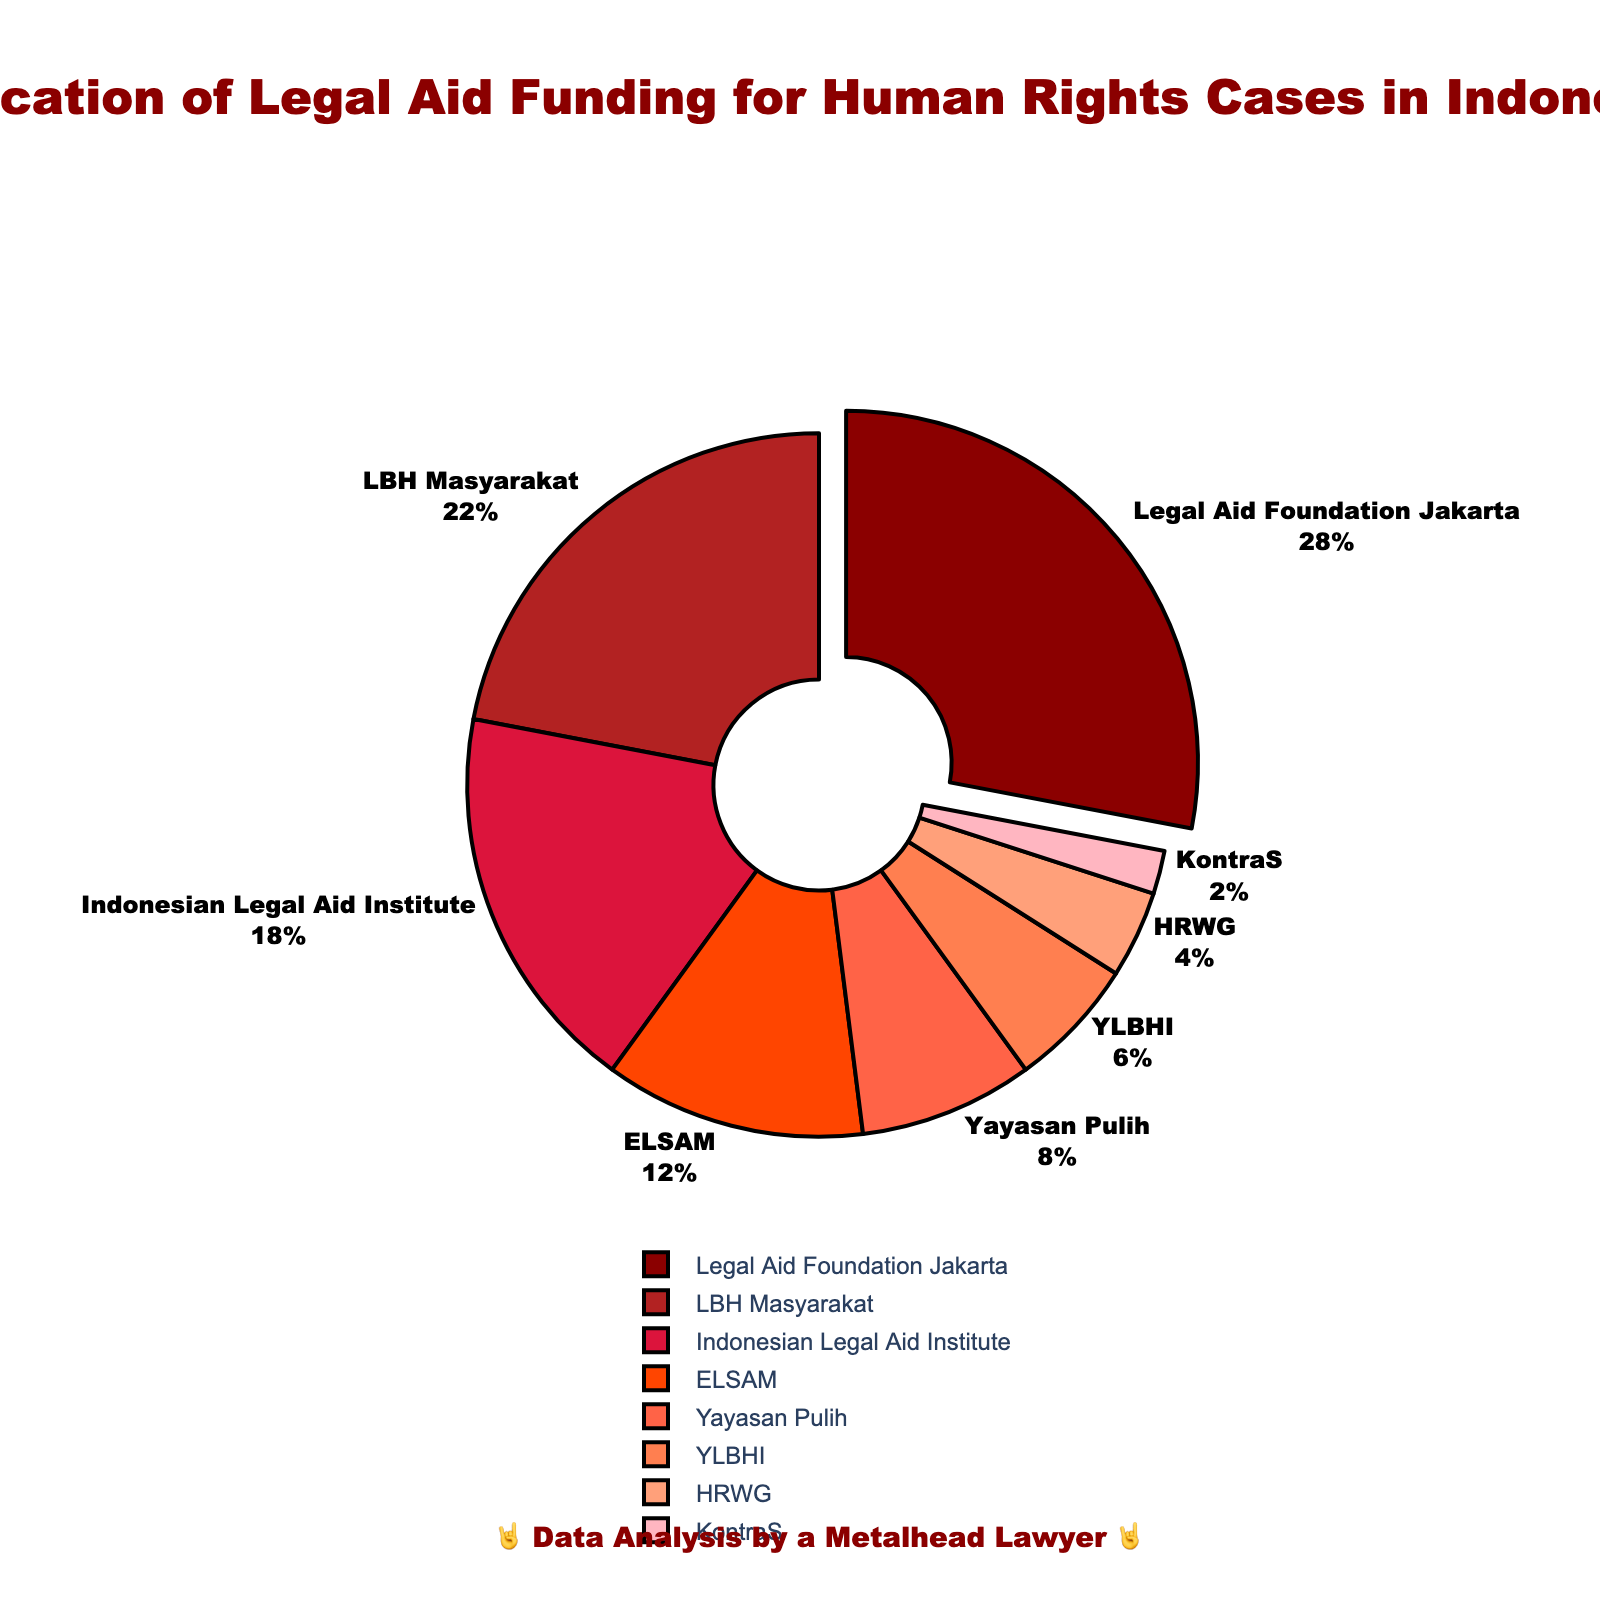Which organization received the highest percentage of legal aid funding? The largest slice of the pie chart, which is slightly pulled out, represents the organization with the highest funding. In this case, it is the Legal Aid Foundation Jakarta with 28%.
Answer: Legal Aid Foundation Jakarta What is the combined percentage of funding for LBH Masyarakat and ELSAM? Identify the slices for LBH Masyarakat (22%) and ELSAM (12%), and then sum these percentages: 22% + 12% = 34%.
Answer: 34% Which organizations received more funding than YLBHI? Verify the percentage of YLBHI (6%). Then, identify the organizations with a higher percentage. The categories with higher percentages are Legal Aid Foundation Jakarta (28%), LBH Masyarakat (22%), Indonesian Legal Aid Institute (18%), ELSAM (12%), and Yayasan Pulih (8%).
Answer: Legal Aid Foundation Jakarta, LBH Masyarakat, Indonesian Legal Aid Institute, ELSAM, Yayasan Pulih What is the difference in funding percentage between Indonesian Legal Aid Institute and Yayasan Pulih? Calculate the difference between the percentages: Indonesian Legal Aid Institute (18%) and Yayasan Pulih (8%). 18% - 8% = 10%.
Answer: 10% Which organization received the least amount of legal aid funding? The smallest slice of the pie chart indicates the organization with the least funding, which is KontraS with 2%.
Answer: KontraS How does the funding for HRWG compare to that for YLBHI? Compare the percentages of HRWG (4%) and YLBHI (6%). YLBHI has a higher funding percentage than HRWG.
Answer: YLBHI has more funding than HRWG What is the total percentage of funding allocated to organizations receiving less than 10% each? Sum the percentages of organizations with less than 10% funding: Yayasan Pulih (8%), YLBHI (6%), HRWG (4%), and KontraS (2%). 8% + 6% + 4% + 2% = 20%.
Answer: 20% Which organization received exactly one-fourth of the total funding? One-fourth of 100% is 25%. The organization closest to this value is the Legal Aid Foundation Jakarta with 28%, but none of the organizations received exactly 25% funding.
Answer: None What proportion of the total funding is allocated to Yayasan Pulih and YLBHI together? Add the percentages for Yayasan Pulih (8%) and YLBHI (6%). 8% + 6% = 14%.
Answer: 14% What is the visual cue that signifies the organization with the maximum funding? The largest slice of the pie chart is pulled out slightly from the rest, indicating that the Legal Aid Foundation Jakarta has the maximum funding of 28%.
Answer: Pulled-out slice If the total legal aid funding equals $100,000, how much funding did LBH Masyarakat receive? Calculate the amount based on the percentage: 22% of $100,000. 22/100 * 100,000 = 22,000.
Answer: $22,000 